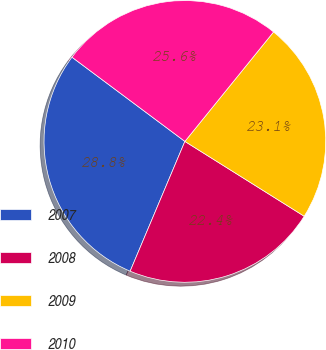Convert chart to OTSL. <chart><loc_0><loc_0><loc_500><loc_500><pie_chart><fcel>2007<fcel>2008<fcel>2009<fcel>2010<nl><fcel>28.85%<fcel>22.44%<fcel>23.08%<fcel>25.64%<nl></chart> 